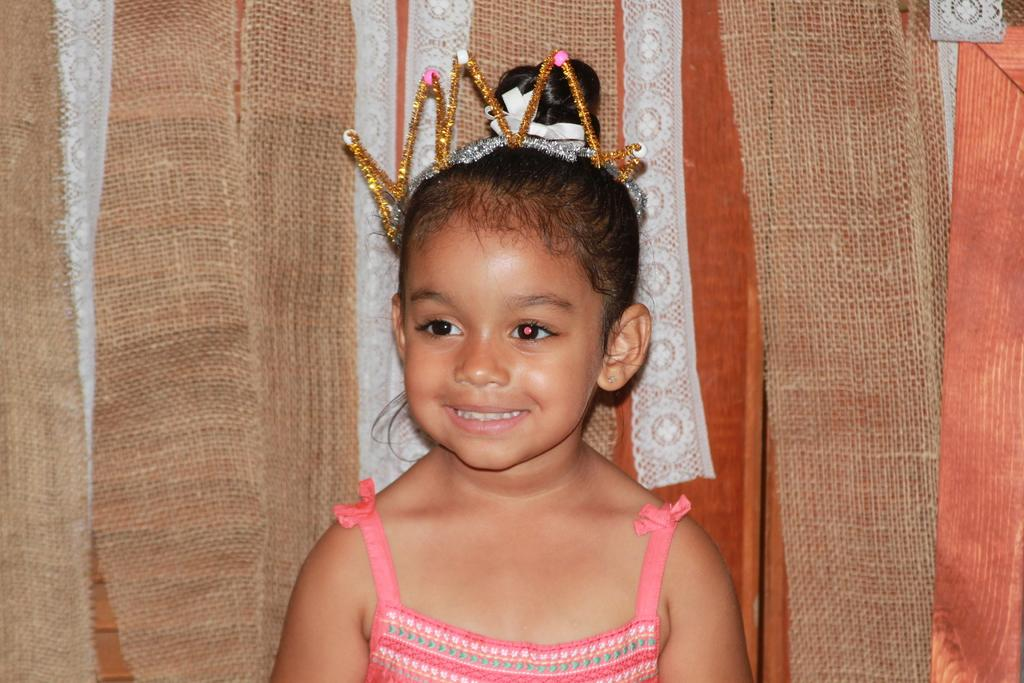Where was the image taken? The image was taken indoors. What can be seen in the background of the image? There are jute cloths in the background. Who is the main subject in the image? There is a kid in the middle of the image. What is the expression on the kid's face? The kid has a smiling face. What is the kid wearing on their head? The kid is wearing a crown. What type of jewel is the kid holding in the image? There is no jewel present in the image; the kid is wearing a crown, but it is not mentioned that they are holding any jewel. 